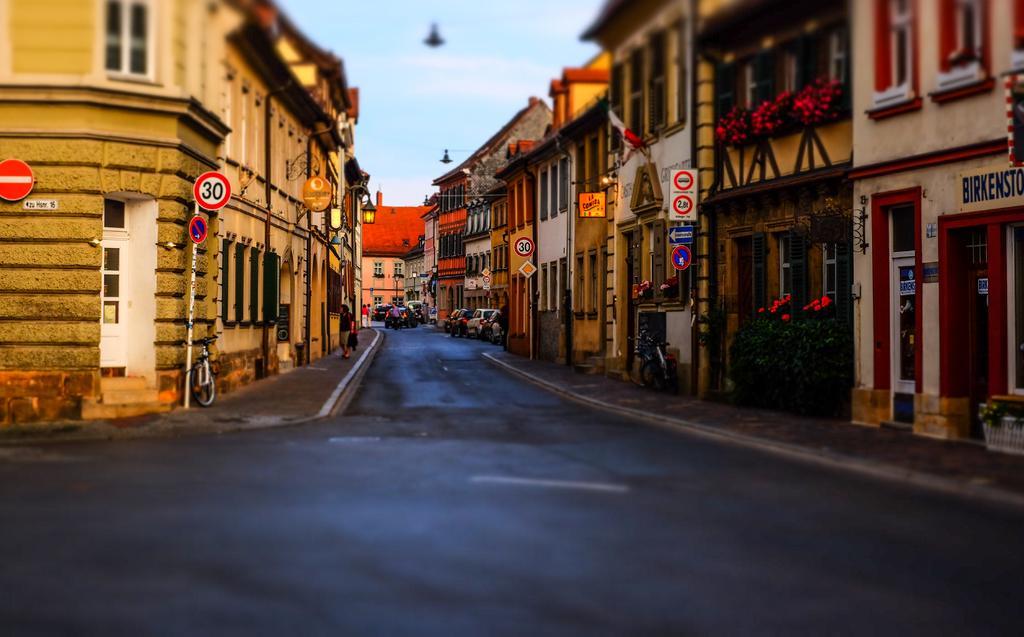In one or two sentences, can you explain what this image depicts? In this picture I can see boards, poles, vehicles, there are plants, lights, houses, there are group of people standing, and in the background there is sky. 